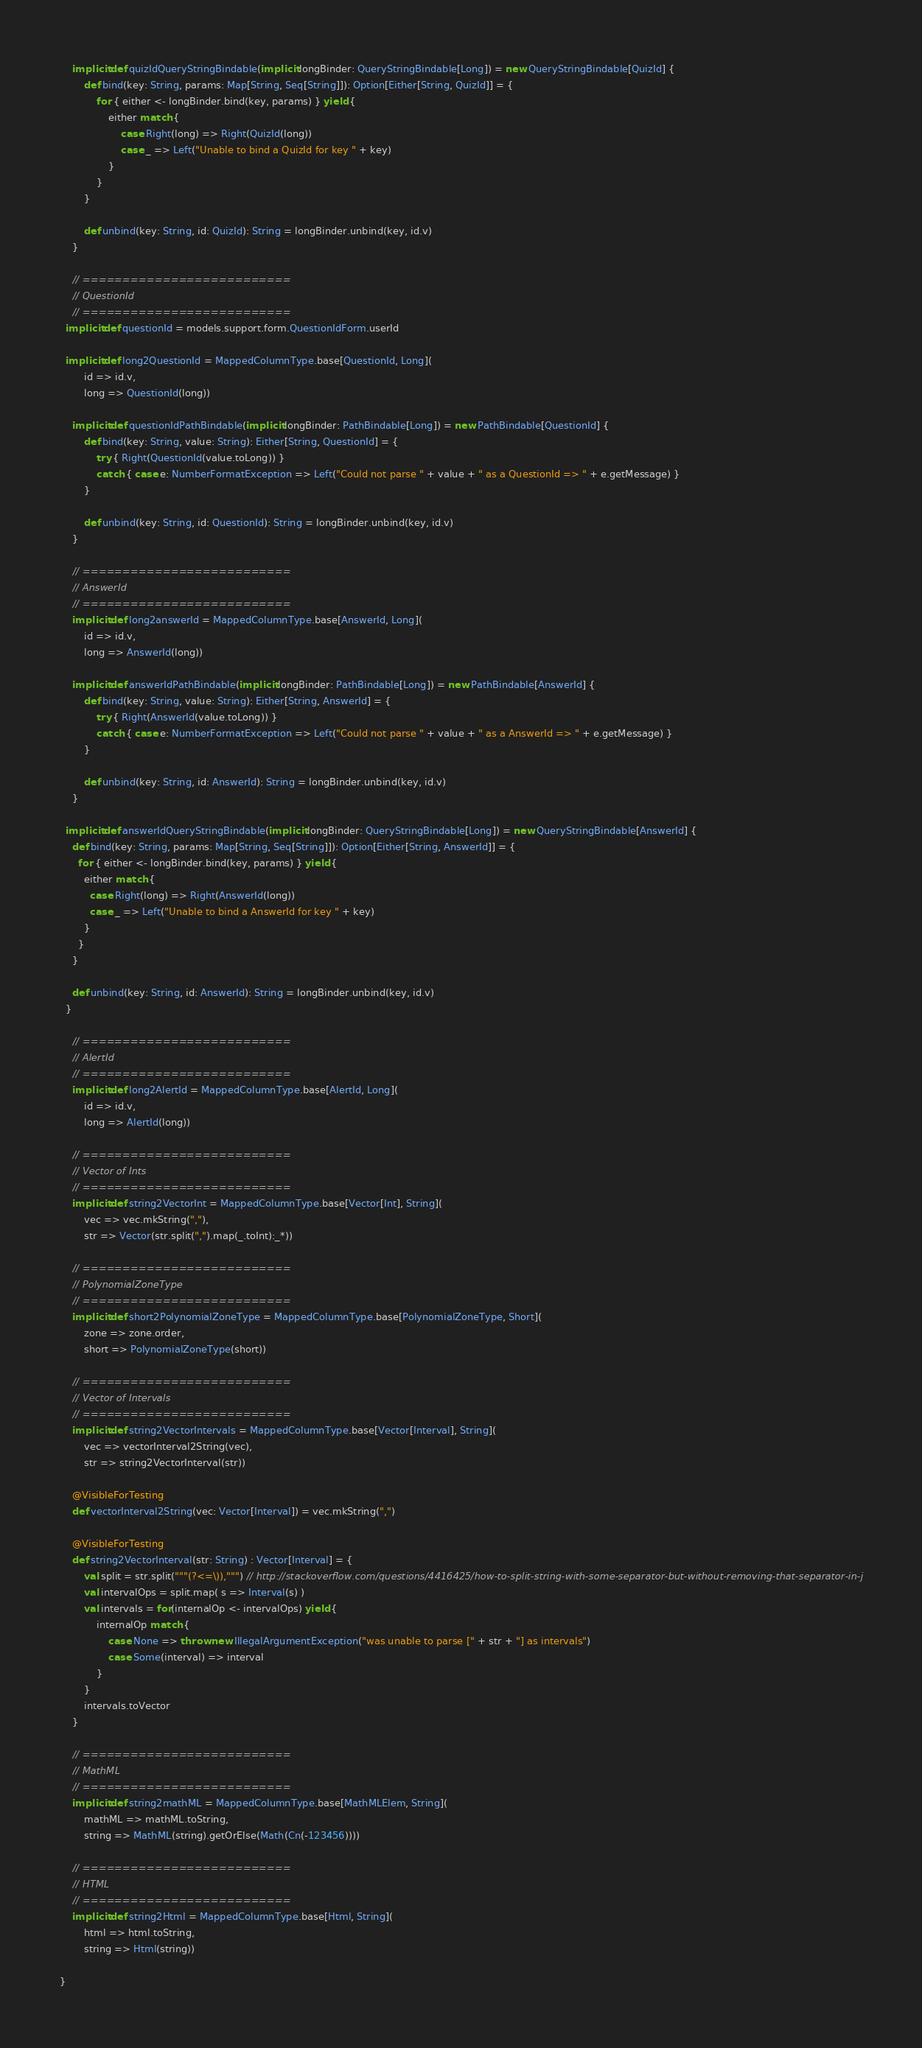Convert code to text. <code><loc_0><loc_0><loc_500><loc_500><_Scala_>	implicit def quizIdQueryStringBindable(implicit longBinder: QueryStringBindable[Long]) = new QueryStringBindable[QuizId] {
		def bind(key: String, params: Map[String, Seq[String]]): Option[Either[String, QuizId]] = {
			for { either <- longBinder.bind(key, params) } yield {
				either match {
					case Right(long) => Right(QuizId(long))
					case _ => Left("Unable to bind a QuizId for key " + key)
				}
			}
		}

		def unbind(key: String, id: QuizId): String = longBinder.unbind(key, id.v)
	}

	// ==========================
	// QuestionId
	// ==========================
  implicit def questionId = models.support.form.QuestionIdForm.userId

  implicit def long2QuestionId = MappedColumnType.base[QuestionId, Long](
		id => id.v,
		long => QuestionId(long))

	implicit def questionIdPathBindable(implicit longBinder: PathBindable[Long]) = new PathBindable[QuestionId] {
		def bind(key: String, value: String): Either[String, QuestionId] = {
			try { Right(QuestionId(value.toLong)) }
			catch { case e: NumberFormatException => Left("Could not parse " + value + " as a QuestionId => " + e.getMessage) }
		}

		def unbind(key: String, id: QuestionId): String = longBinder.unbind(key, id.v)
	}

	// ==========================
	// AnswerId
	// ==========================
	implicit def long2answerId = MappedColumnType.base[AnswerId, Long](
		id => id.v,
		long => AnswerId(long))

	implicit def answerIdPathBindable(implicit longBinder: PathBindable[Long]) = new PathBindable[AnswerId] {
		def bind(key: String, value: String): Either[String, AnswerId] = {
			try { Right(AnswerId(value.toLong)) }
			catch { case e: NumberFormatException => Left("Could not parse " + value + " as a AnswerId => " + e.getMessage) }
		}

		def unbind(key: String, id: AnswerId): String = longBinder.unbind(key, id.v)
	}

  implicit def answerIdQueryStringBindable(implicit longBinder: QueryStringBindable[Long]) = new QueryStringBindable[AnswerId] {
    def bind(key: String, params: Map[String, Seq[String]]): Option[Either[String, AnswerId]] = {
      for { either <- longBinder.bind(key, params) } yield {
        either match {
          case Right(long) => Right(AnswerId(long))
          case _ => Left("Unable to bind a AnswerId for key " + key)
        }
      }
    }

    def unbind(key: String, id: AnswerId): String = longBinder.unbind(key, id.v)
  }

	// ==========================
	// AlertId
	// ==========================
	implicit def long2AlertId = MappedColumnType.base[AlertId, Long](
		id => id.v,
		long => AlertId(long))

	// ==========================
	// Vector of Ints
	// ==========================
	implicit def string2VectorInt = MappedColumnType.base[Vector[Int], String](
		vec => vec.mkString(","),
		str => Vector(str.split(",").map(_.toInt):_*))

	// ==========================
	// PolynomialZoneType
	// ==========================
	implicit def short2PolynomialZoneType = MappedColumnType.base[PolynomialZoneType, Short](
		zone => zone.order,
		short => PolynomialZoneType(short))

	// ==========================
	// Vector of Intervals
	// ==========================
	implicit def string2VectorIntervals = MappedColumnType.base[Vector[Interval], String](
		vec => vectorInterval2String(vec),
		str => string2VectorInterval(str))

	@VisibleForTesting
	def vectorInterval2String(vec: Vector[Interval]) = vec.mkString(",")

	@VisibleForTesting
	def string2VectorInterval(str: String) : Vector[Interval] = {
		val split = str.split("""(?<=\)),""") // http://stackoverflow.com/questions/4416425/how-to-split-string-with-some-separator-but-without-removing-that-separator-in-j
		val intervalOps = split.map( s => Interval(s) )
		val intervals = for(internalOp <- intervalOps) yield {
			internalOp match {
				case None => throw new IllegalArgumentException("was unable to parse [" + str + "] as intervals")
				case Some(interval) => interval
			}
		}
		intervals.toVector
	}

	// ==========================
	// MathML
	// ==========================
	implicit def string2mathML = MappedColumnType.base[MathMLElem, String](
		mathML => mathML.toString,
		string => MathML(string).getOrElse(Math(Cn(-123456))))

	// ==========================
	// HTML
	// ==========================
	implicit def string2Html = MappedColumnType.base[Html, String](
		html => html.toString,
		string => Html(string))

}


</code> 